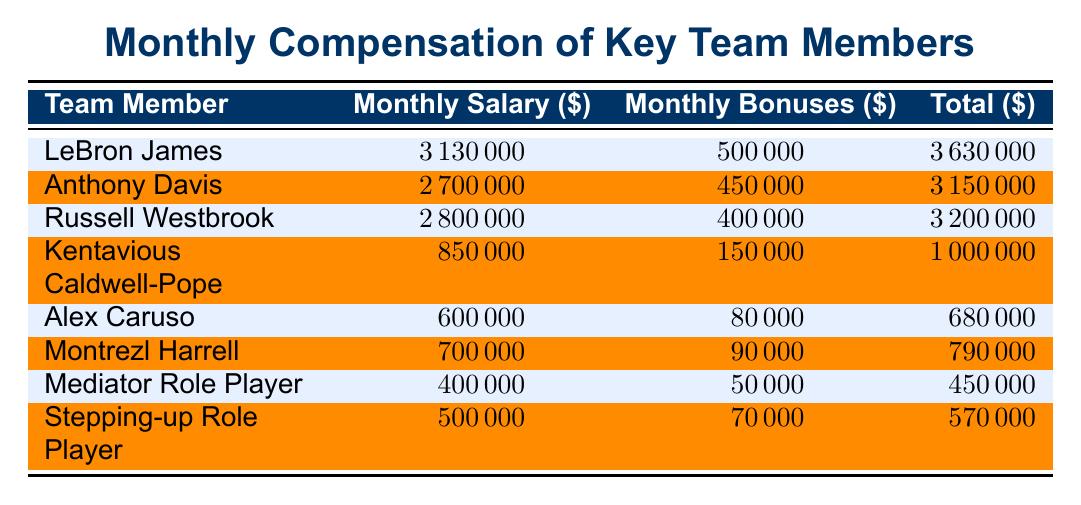What is LeBron James's total monthly compensation? LeBron James's total monthly compensation is found directly in the table under the 'Total' column. His entry shows a total of 3630000.
Answer: 3630000 What is the monthly salary of Anthony Davis? The monthly salary of Anthony Davis can be found in the 'Monthly Salary' column next to his name. It shows as 2700000.
Answer: 2700000 Is Montrezl Harrell's monthly bonuses higher than those of Alex Caruso? Montrezl Harrell's monthly bonuses are listed as 90000 while Alex Caruso's are 80000. Since 90000 is greater than 80000, the statement is true.
Answer: Yes What is the combined total monthly compensation of the Mediator Role Player and the Stepping-up Role Player? To find the combined total monthly compensation, add the totals for both players: Mediator Role Player has a total of 450000 and the Stepping-up Role Player has 570000. The sum is 450000 + 570000 = 1020000.
Answer: 1020000 Which player has the highest monthly salary? To determine which player has the highest monthly salary, compare the values in the 'Monthly Salary' column. LeBron James has the highest salary at 3130000.
Answer: LeBron James 